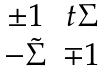Convert formula to latex. <formula><loc_0><loc_0><loc_500><loc_500>\begin{matrix} \pm 1 & t \Sigma \\ - \tilde { \Sigma } & \mp 1 \end{matrix}</formula> 